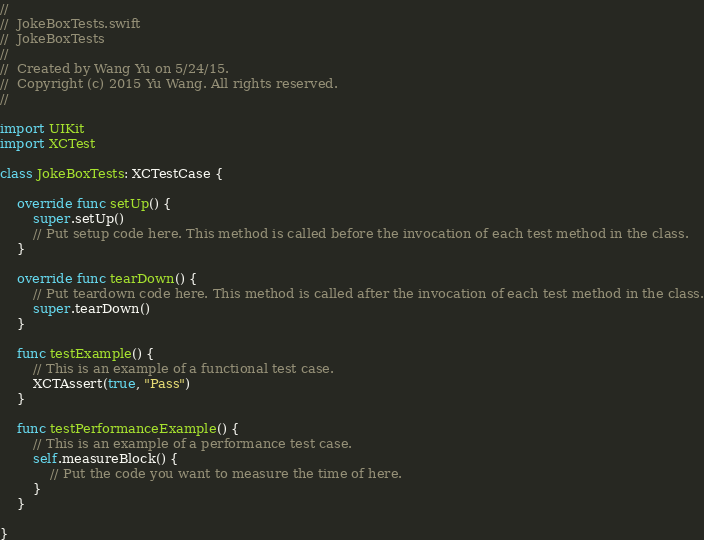Convert code to text. <code><loc_0><loc_0><loc_500><loc_500><_Swift_>//
//  JokeBoxTests.swift
//  JokeBoxTests
//
//  Created by Wang Yu on 5/24/15.
//  Copyright (c) 2015 Yu Wang. All rights reserved.
//

import UIKit
import XCTest

class JokeBoxTests: XCTestCase {
    
    override func setUp() {
        super.setUp()
        // Put setup code here. This method is called before the invocation of each test method in the class.
    }
    
    override func tearDown() {
        // Put teardown code here. This method is called after the invocation of each test method in the class.
        super.tearDown()
    }
    
    func testExample() {
        // This is an example of a functional test case.
        XCTAssert(true, "Pass")
    }
    
    func testPerformanceExample() {
        // This is an example of a performance test case.
        self.measureBlock() {
            // Put the code you want to measure the time of here.
        }
    }
    
}
</code> 